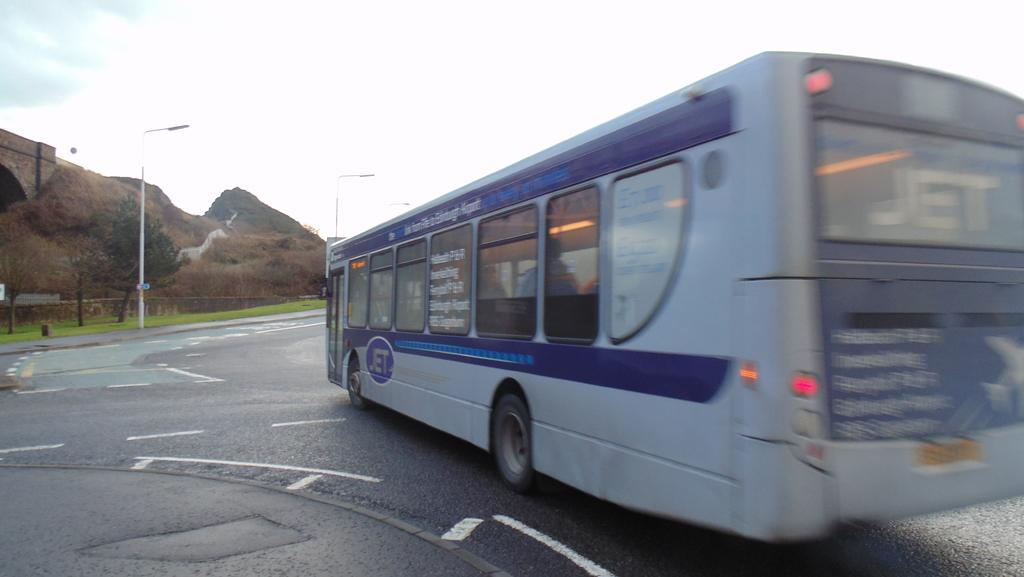What type of vehicle is in the image? There is a bus on a road in the image. What can be seen in the background of the image? There are light poles, trees, mountains, and the sky visible in the background of the image. How many different types of objects can be seen in the background? There are four different types of objects in the background: light poles, trees, mountains, and the sky. How many bars of soap are on the bus in the image? There are no bars of soap present on the bus in the image. What type of boy can be seen playing with the light poles in the image? There is no boy present in the image, and the light poles are not being interacted with. 